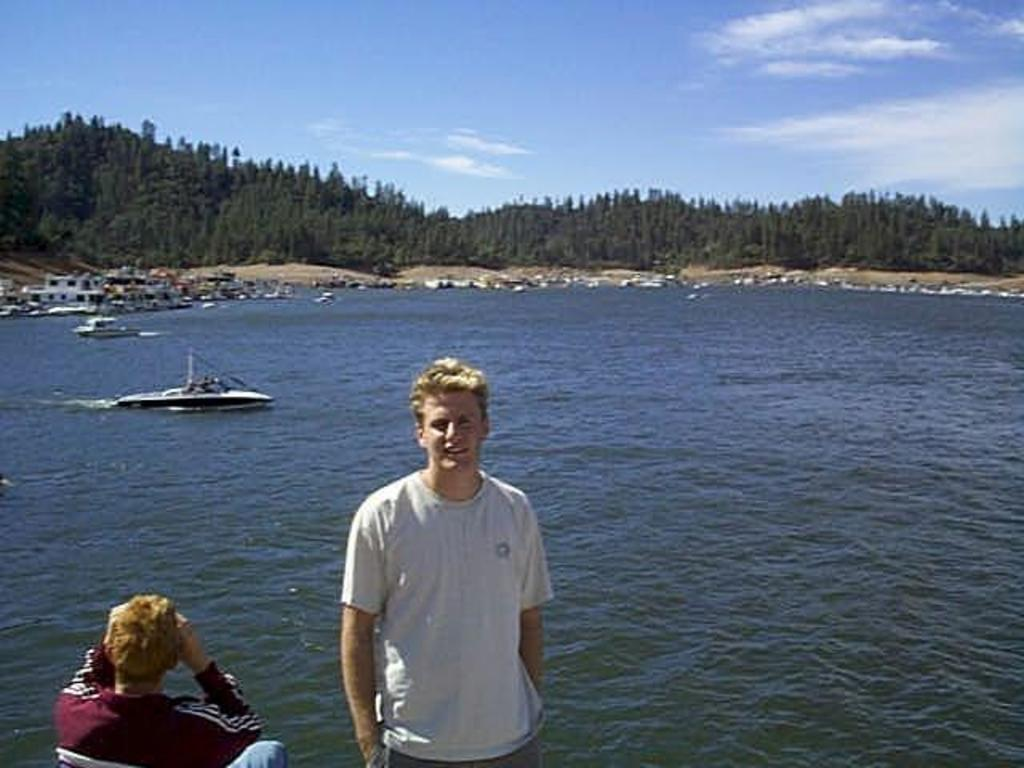What type of vegetation can be seen in the image? There are trees in the image. What can be seen in the water in the image? There are boats in the water in the image. How many men are present in the image? There are two men in the image, one standing and one seated. How would you describe the sky in the image? The sky is blue and cloudy in the image. Can you hear the voice of the visitor in the image? There is no visitor present in the image, so there is no voice to hear. Are the two men in the image having an argument? The image does not provide any information about the men's conversation or interactions, so it cannot be determined if they are having an argument. 